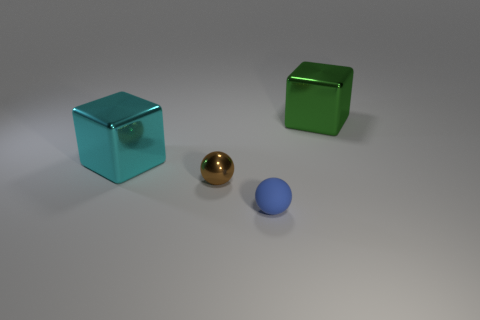Is there a large cube that is to the right of the large thing that is behind the large cyan cube?
Offer a very short reply. No. Does the tiny metal thing left of the small blue matte ball have the same shape as the big cyan thing?
Your answer should be compact. No. Is there anything else that has the same shape as the green object?
Provide a short and direct response. Yes. What number of spheres are either tiny brown things or big shiny objects?
Keep it short and to the point. 1. How many cyan metal balls are there?
Ensure brevity in your answer.  0. What size is the shiny thing that is behind the large shiny cube that is to the left of the brown metallic ball?
Provide a succinct answer. Large. How many other things are the same size as the brown ball?
Offer a terse response. 1. There is a big green metallic cube; what number of matte things are behind it?
Provide a short and direct response. 0. How big is the blue thing?
Keep it short and to the point. Small. Are the thing that is in front of the tiny brown object and the large block that is behind the cyan object made of the same material?
Make the answer very short. No. 